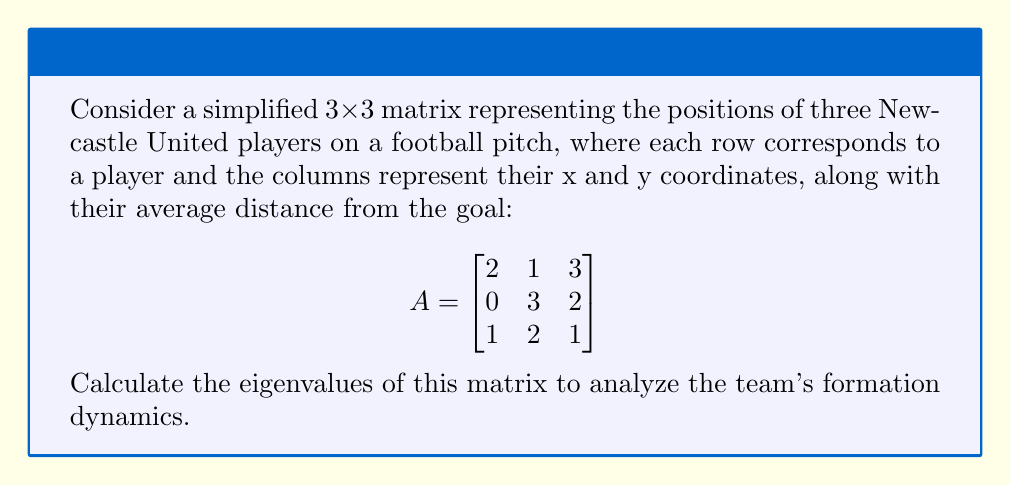Solve this math problem. To find the eigenvalues of matrix A, we need to solve the characteristic equation:

1) First, we set up the equation $det(A - \lambda I) = 0$, where $\lambda$ represents the eigenvalues and I is the 3x3 identity matrix:

   $$det\begin{pmatrix}
   2-\lambda & 1 & 3 \\
   0 & 3-\lambda & 2 \\
   1 & 2 & 1-\lambda
   \end{pmatrix} = 0$$

2) Expand the determinant:
   $$(2-\lambda)[(3-\lambda)(1-\lambda) - 4] - 1[0 - 3(1-\lambda)] + 3[0 - (3-\lambda)] = 0$$

3) Simplify:
   $$(2-\lambda)[\lambda^2 - 4\lambda + 3 - 4] + 3(1-\lambda) - 3(3-\lambda) = 0$$
   $$(2-\lambda)(\lambda^2 - 4\lambda - 1) + 3 - 3\lambda - 9 + 3\lambda = 0$$
   $$2\lambda^2 - 8\lambda - 2 - \lambda^3 + 4\lambda^2 + \lambda - 6 = 0$$

4) Rearrange to standard form:
   $$-\lambda^3 + 6\lambda^2 - 7\lambda - 8 = 0$$

5) This cubic equation can be solved using various methods. One eigenvalue can be found by inspection: $\lambda = 1$ is a solution.

6) Factoring out $(λ - 1)$:
   $$(\lambda - 1)(-\lambda^2 + 5\lambda - 8) = 0$$

7) Solve the quadratic equation $-\lambda^2 + 5\lambda - 8 = 0$ using the quadratic formula:
   $$\lambda = \frac{-5 \pm \sqrt{25 + 32}}{-2} = \frac{-5 \pm \sqrt{57}}{-2}$$

Therefore, the eigenvalues are:
$\lambda_1 = 1$
$\lambda_2 = \frac{5 + \sqrt{57}}{2}$
$\lambda_3 = \frac{5 - \sqrt{57}}{2}$
Answer: $\lambda_1 = 1$, $\lambda_2 = \frac{5 + \sqrt{57}}{2}$, $\lambda_3 = \frac{5 - \sqrt{57}}{2}$ 